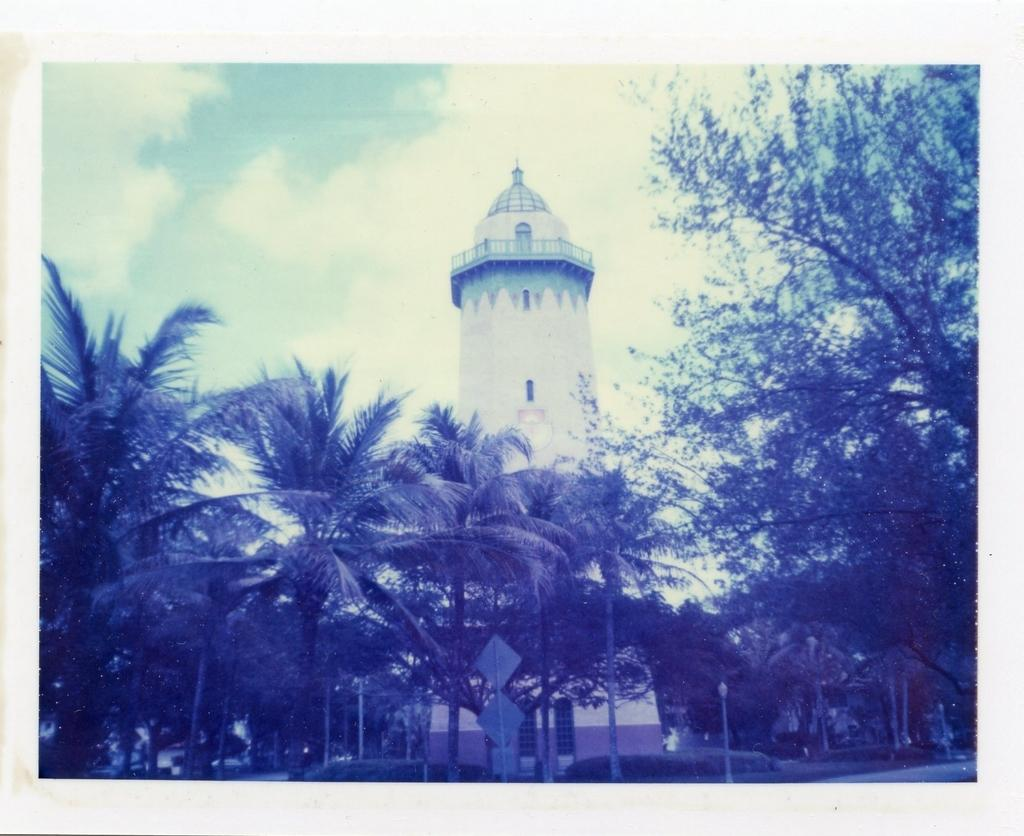What is the main subject of the image? There is a photo in the image. What else can be seen in the image besides the photo? There is a building, poles, boards, trees, and the sky is visible in the background of the image. How many tomatoes are on the ground in the image? There are no tomatoes present in the image. What type of toys can be seen in the image? There are no toys present in the image. 